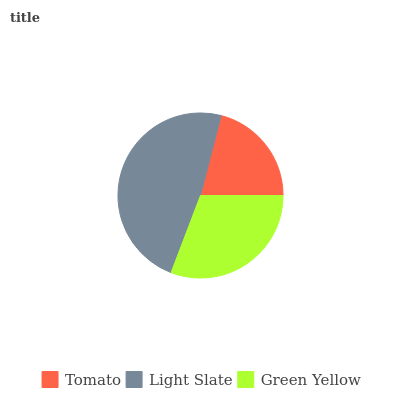Is Tomato the minimum?
Answer yes or no. Yes. Is Light Slate the maximum?
Answer yes or no. Yes. Is Green Yellow the minimum?
Answer yes or no. No. Is Green Yellow the maximum?
Answer yes or no. No. Is Light Slate greater than Green Yellow?
Answer yes or no. Yes. Is Green Yellow less than Light Slate?
Answer yes or no. Yes. Is Green Yellow greater than Light Slate?
Answer yes or no. No. Is Light Slate less than Green Yellow?
Answer yes or no. No. Is Green Yellow the high median?
Answer yes or no. Yes. Is Green Yellow the low median?
Answer yes or no. Yes. Is Light Slate the high median?
Answer yes or no. No. Is Tomato the low median?
Answer yes or no. No. 